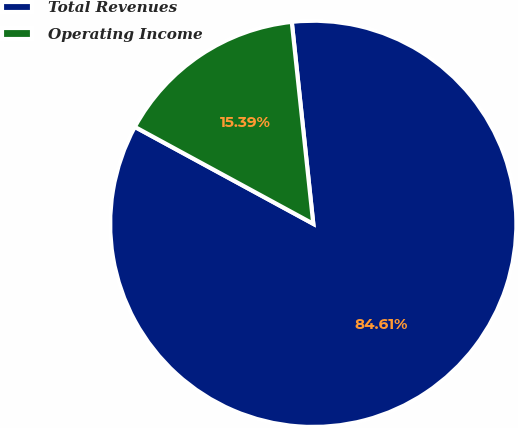Convert chart to OTSL. <chart><loc_0><loc_0><loc_500><loc_500><pie_chart><fcel>Total Revenues<fcel>Operating Income<nl><fcel>84.61%<fcel>15.39%<nl></chart> 